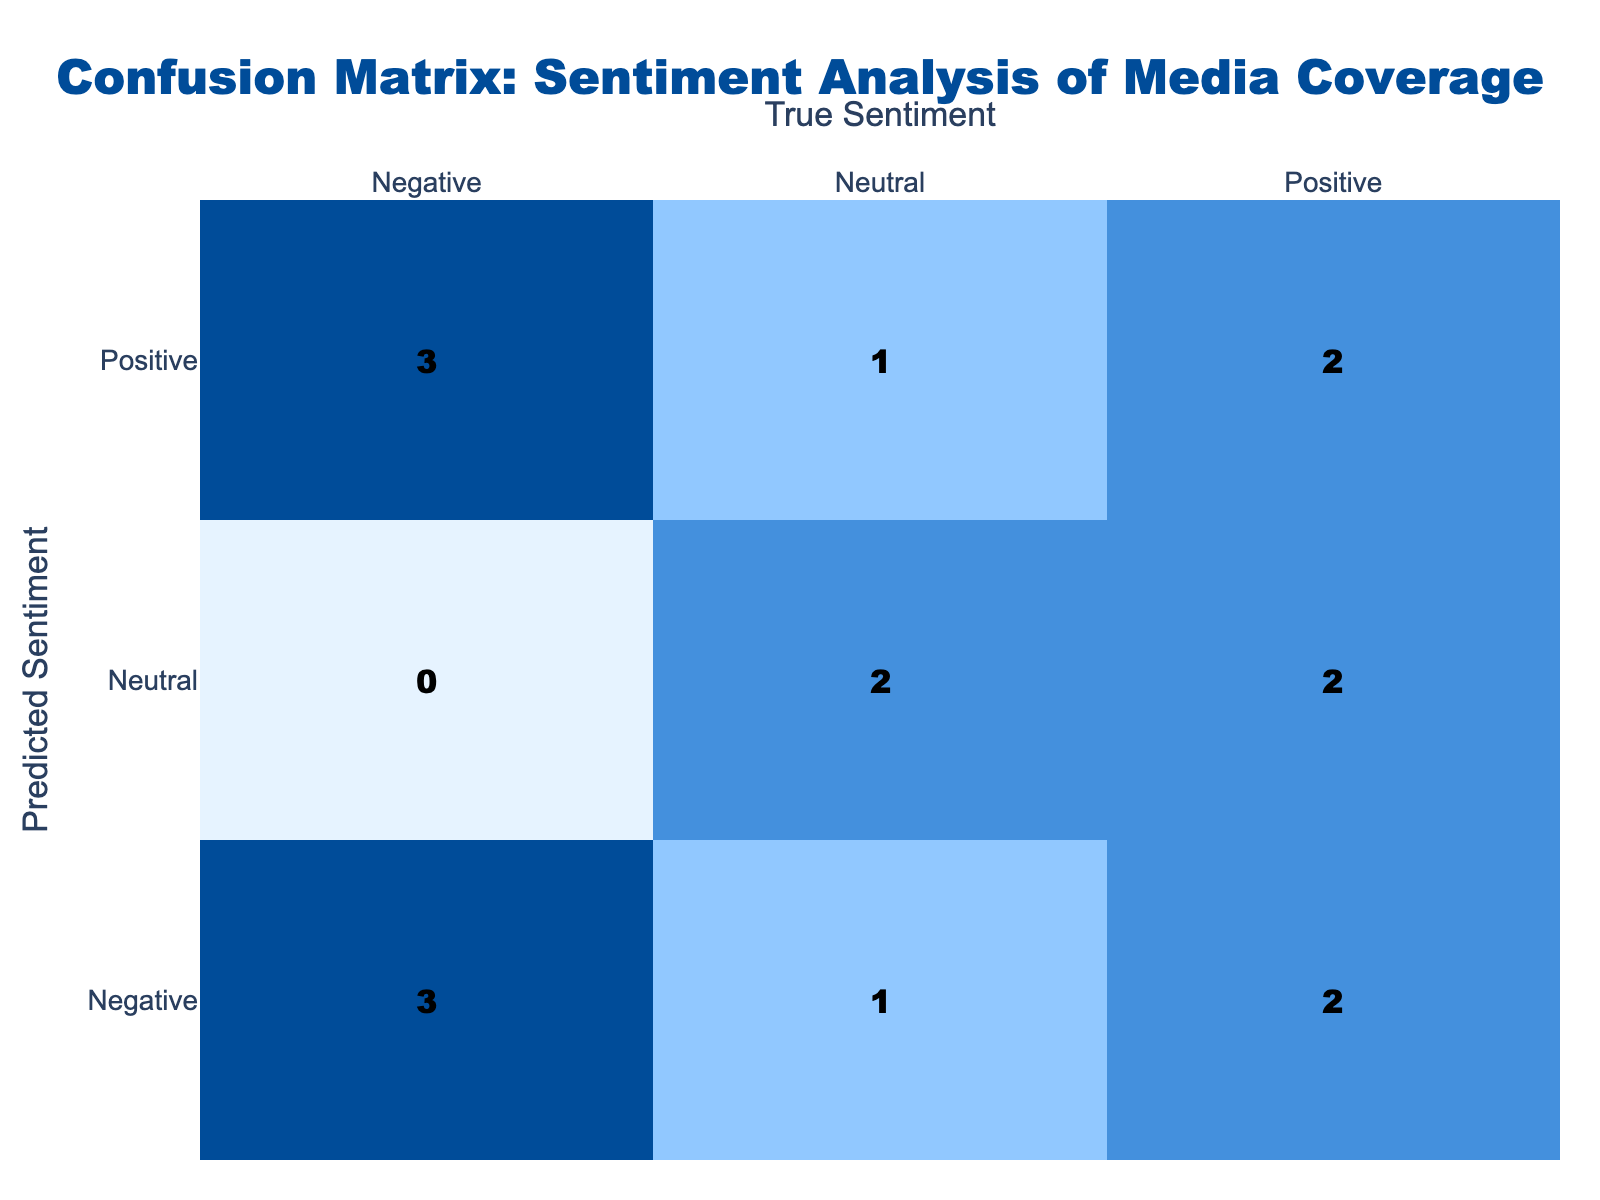What is the total number of instances where the predicted sentiment is "Positive"? From the confusion matrix, we look at the "Positive" row. The values in that row are (1, 2, 1), which represent the counts of "Positive" predictions corresponding to "Positive," "Negative," and "Neutral" true sentiments, respectively. Adding these values gives us 1 + 2 + 1 = 4.
Answer: 4 How many times was the true sentiment "Negative" predicted as "Positive"? We need to focus on the "Negative" true sentiment column in the confusion matrix. The cell where predicted sentiment is "Positive" and true sentiment is "Negative" has a value of 2. This indicates that out of the total predictions, "Negative" true sentiments were incorrectly predicted as "Positive" 2 times.
Answer: 2 What is the total number of correctly predicted sentiments? To find this, we sum the values on the diagonal of the confusion matrix where predicted and true sentiments match, which are (1, 3, 2) for "Positive," "Negative," and "Neutral," respectively. Adding these values together gives 1 + 3 + 2 = 6 correct predictions.
Answer: 6 How many instances of "Neutral" true sentiment were misclassified? We focus on the "Neutral" true sentiment column, examining where the predicted sentiments are not "Neutral." The values corresponding to misclassifications are in the "Positive" and "Negative" rows, which are (2, 2). Adding these values gives us 2 + 2 = 4. Therefore, the total number of misclassified "Neutral" sentiments is 4.
Answer: 4 Is it true that the predicted sentiment was "Negative" for all instances of true sentiment "Negative"? We check the "Negative" row's values. The count where the predicted sentiment is "Negative" and true sentiment is also "Negative" is 3, but we also had instances of "Positive" predicted. Therefore, it is not true that all predicted sentiments were "Negative."
Answer: No What is the difference between the number of times "Positive" was predicted versus "Negative"? We need to find the total counts for both "Positive" and "Negative" predicted sentiments. Summing the "Positive" row yields 4 (1+2+1), while the "Negative" row gives 5 (3+2+0). The difference can now be calculated as 5 (Negative) - 4 (Positive) = 1.
Answer: 1 How many total instances of "Neutral" predictions were made? To determine this, we review the "Neutral" row in the confusion matrix. The values there are (2, 0, 2), representing instances of both true "Positive" and "Negative" sentiments predicted as "Neutral." Adding those values gives a total of 4 instances where "Neutral" predictions occurred.
Answer: 4 What percentage of "Positive" true sentiments were predicted correctly? We find the occurrence of true "Positive" sentiments and then check matching predictions. The true "Positive" is represented as 1 in the confusion matrix, and the correctly predicted is also 1. To calculate the percentage, we use the formula: (correct predictions / total true instances) * 100 = (1/1)*100 = 100%.
Answer: 100% 